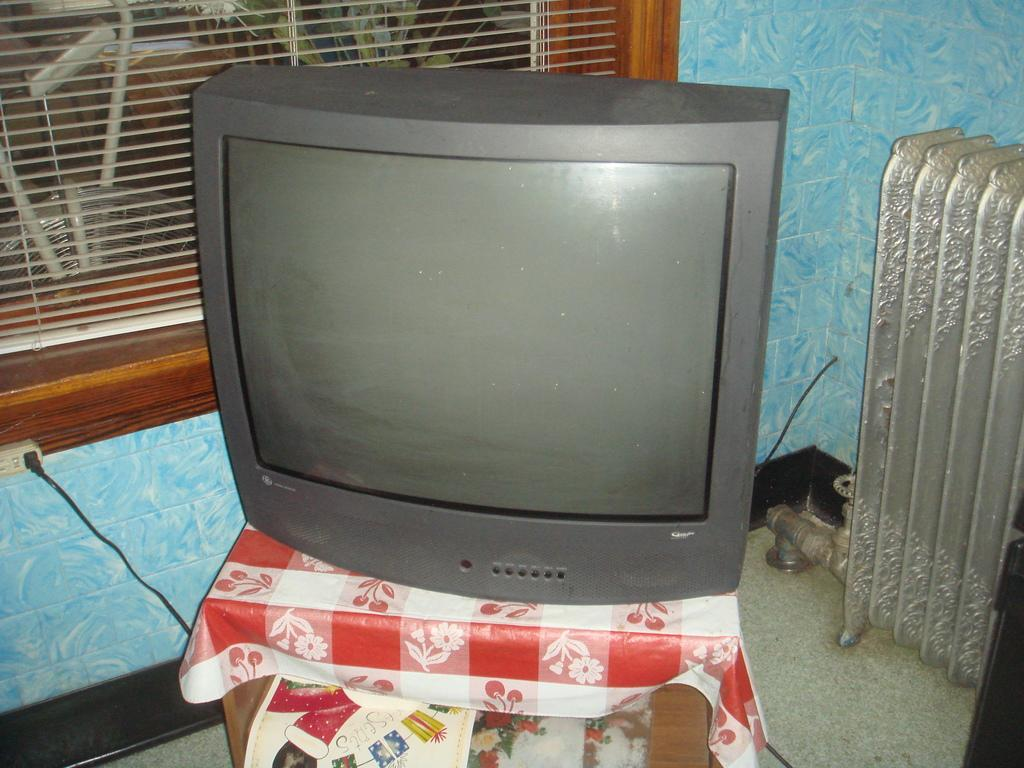What is the main object in the middle of the picture? There is a television in the middle of the picture. What type of furniture is located at the bottom of the picture? There is a stool in the bottom of the picture. What can be seen in the background of the picture? There are window blinds in the background of the picture. What type of tramp is visible in the picture? There is no tramp present in the picture. What order is being followed in the picture? The picture does not depict any specific order or sequence of events. 